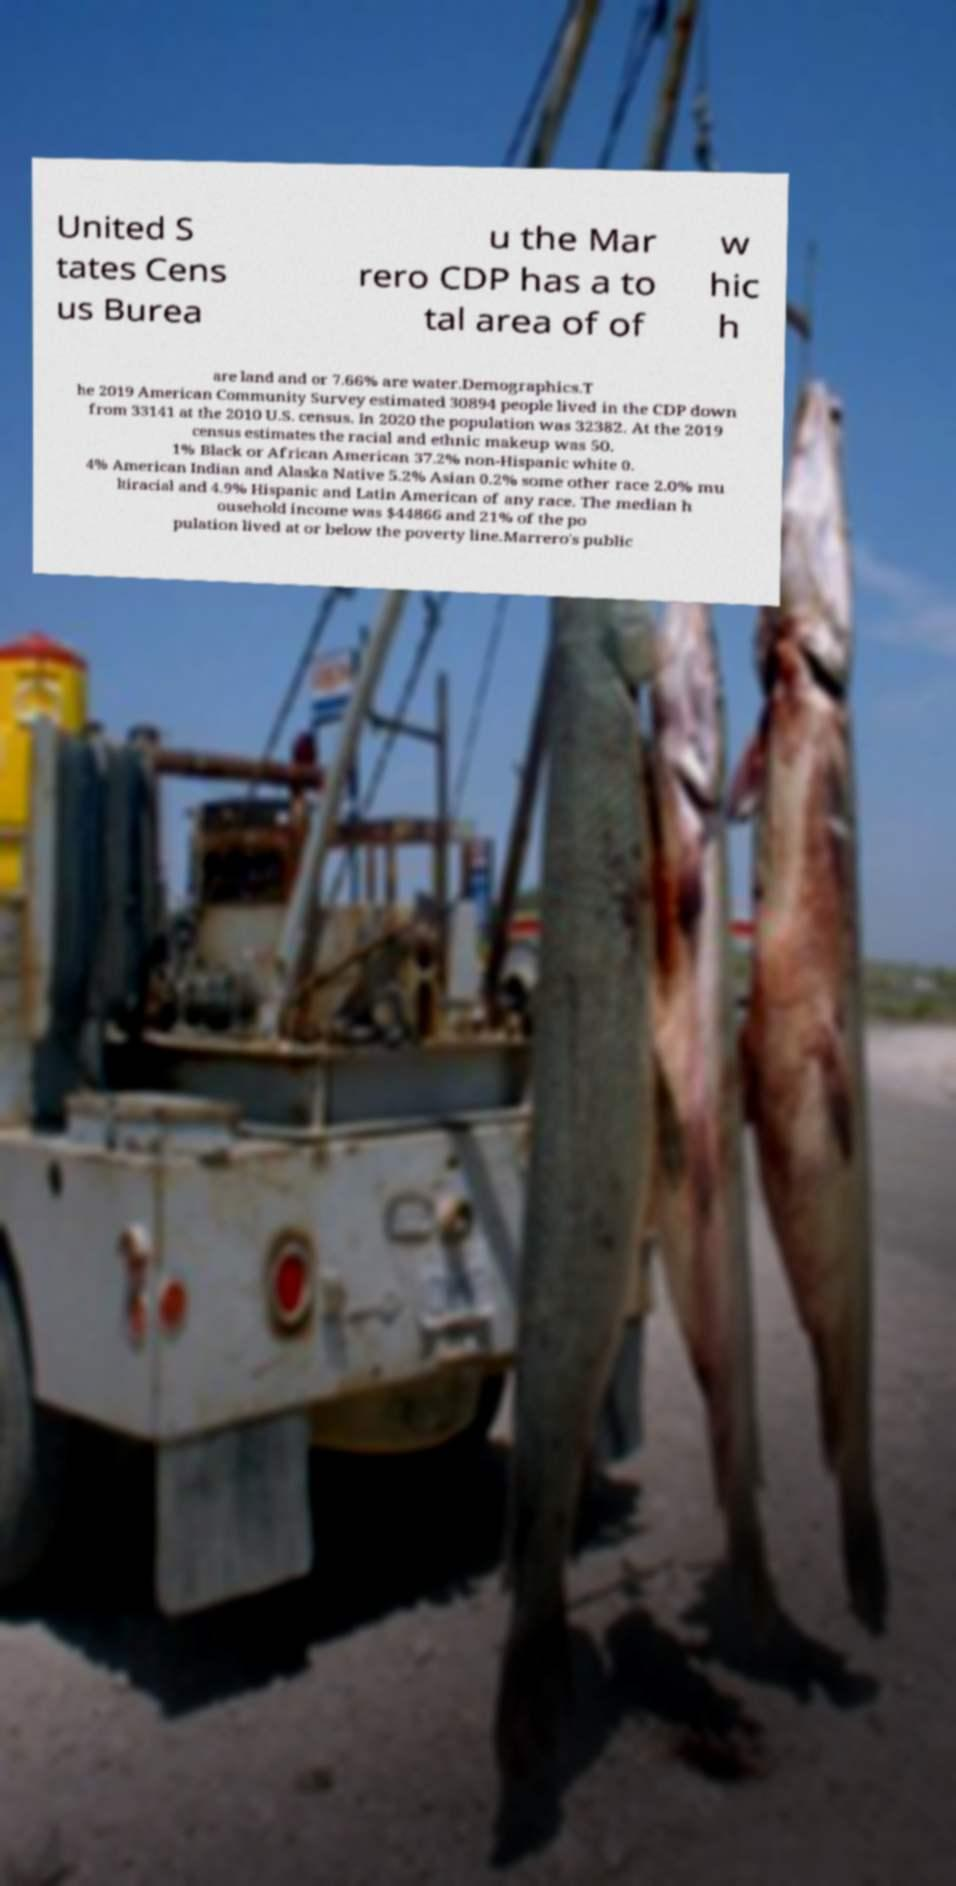I need the written content from this picture converted into text. Can you do that? United S tates Cens us Burea u the Mar rero CDP has a to tal area of of w hic h are land and or 7.66% are water.Demographics.T he 2019 American Community Survey estimated 30894 people lived in the CDP down from 33141 at the 2010 U.S. census. In 2020 the population was 32382. At the 2019 census estimates the racial and ethnic makeup was 50. 1% Black or African American 37.2% non-Hispanic white 0. 4% American Indian and Alaska Native 5.2% Asian 0.2% some other race 2.0% mu ltiracial and 4.9% Hispanic and Latin American of any race. The median h ousehold income was $44866 and 21% of the po pulation lived at or below the poverty line.Marrero's public 